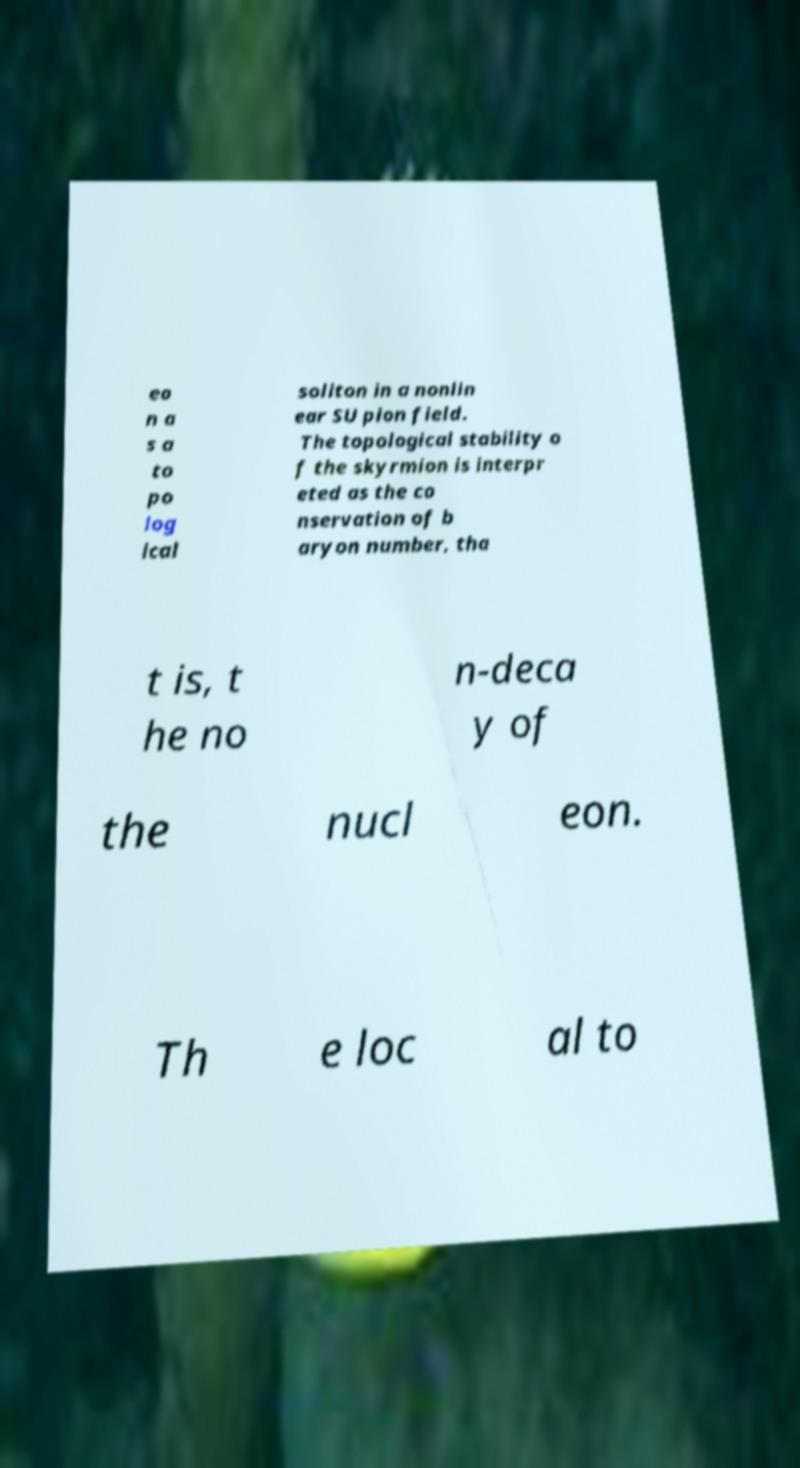What messages or text are displayed in this image? I need them in a readable, typed format. eo n a s a to po log ical soliton in a nonlin ear SU pion field. The topological stability o f the skyrmion is interpr eted as the co nservation of b aryon number, tha t is, t he no n-deca y of the nucl eon. Th e loc al to 